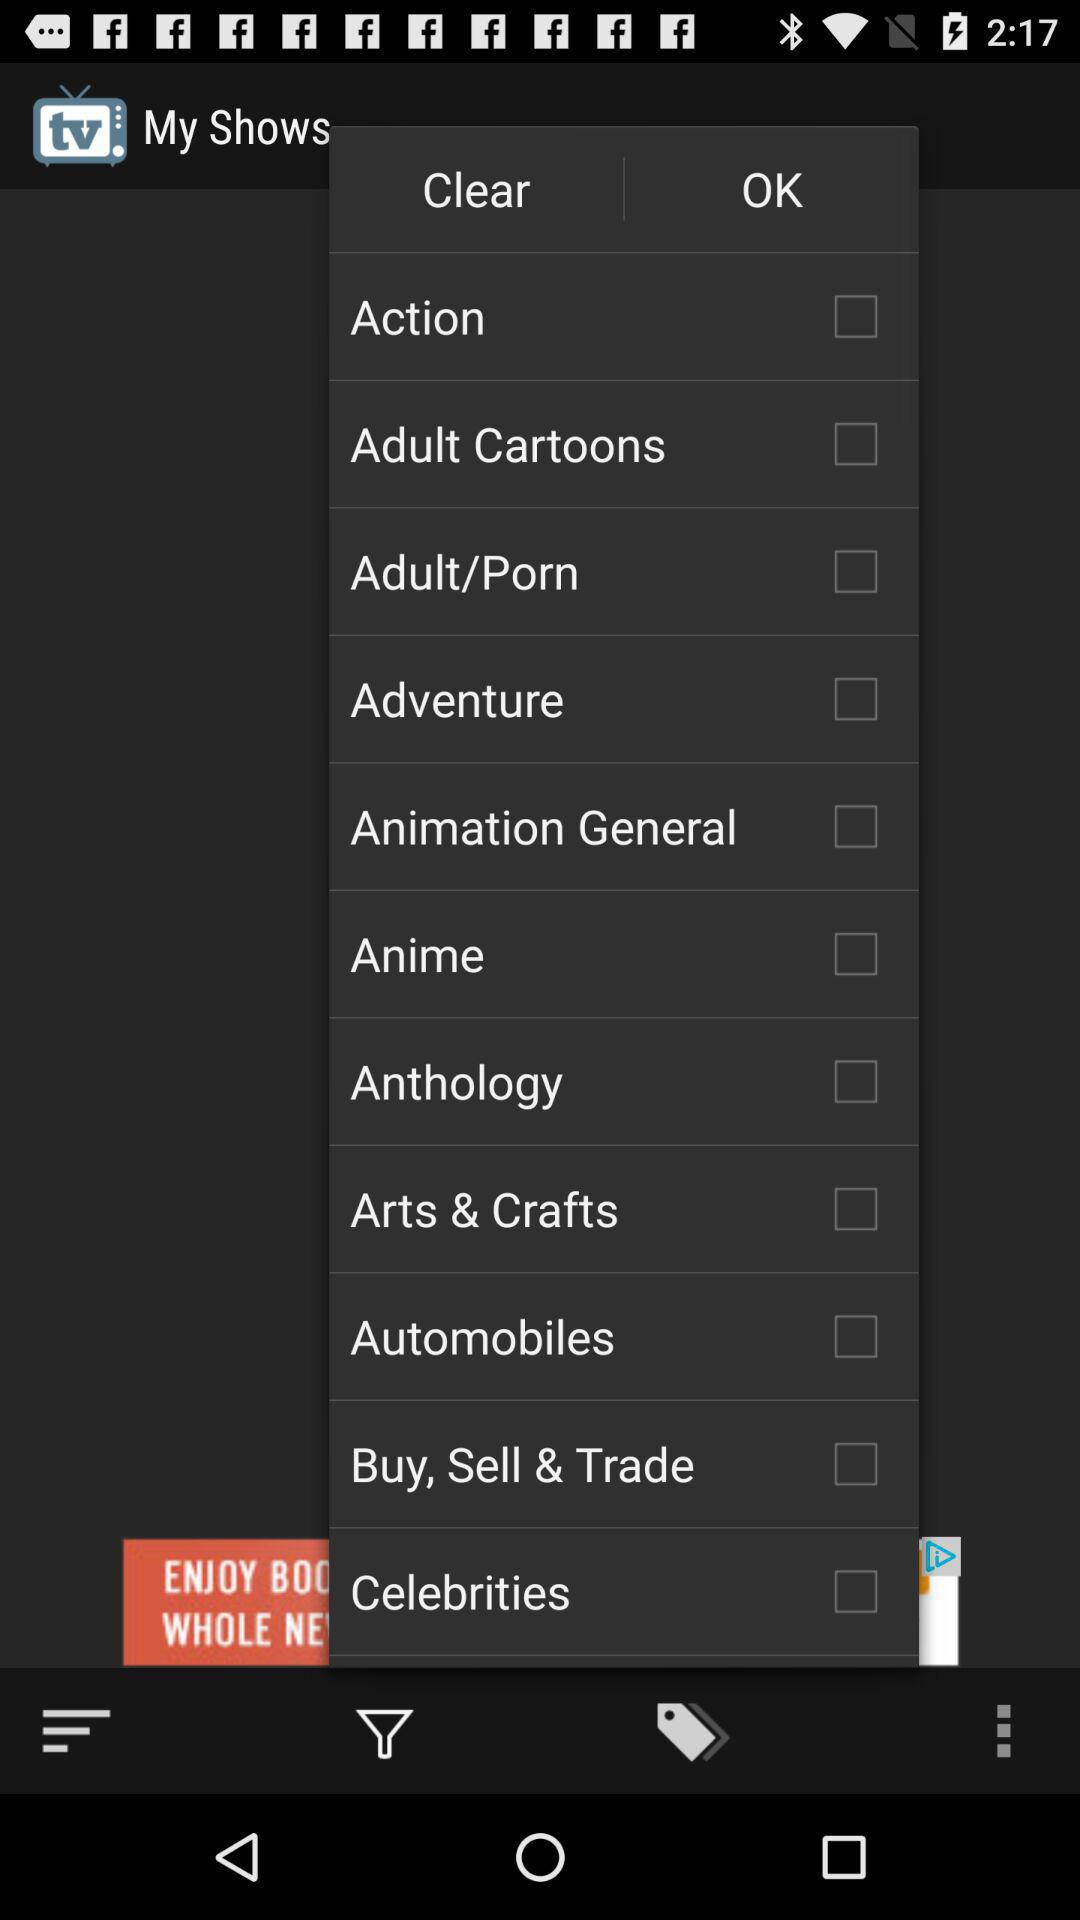What is the status of "Action"? The status of "Action" is "on". 